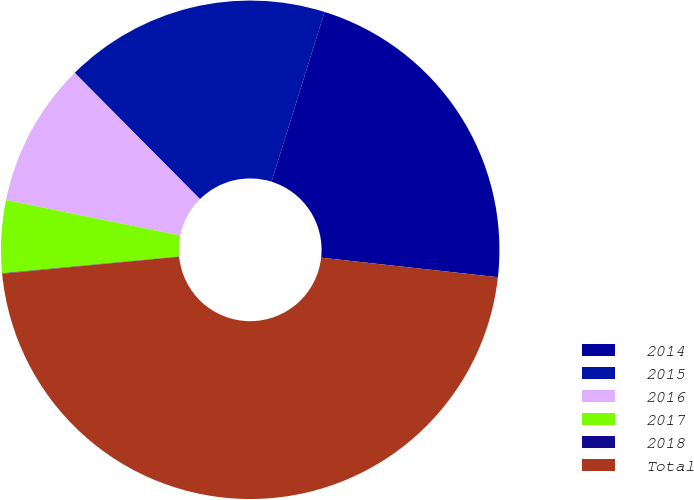Convert chart to OTSL. <chart><loc_0><loc_0><loc_500><loc_500><pie_chart><fcel>2014<fcel>2015<fcel>2016<fcel>2017<fcel>2018<fcel>Total<nl><fcel>21.93%<fcel>17.26%<fcel>9.37%<fcel>4.7%<fcel>0.03%<fcel>46.71%<nl></chart> 